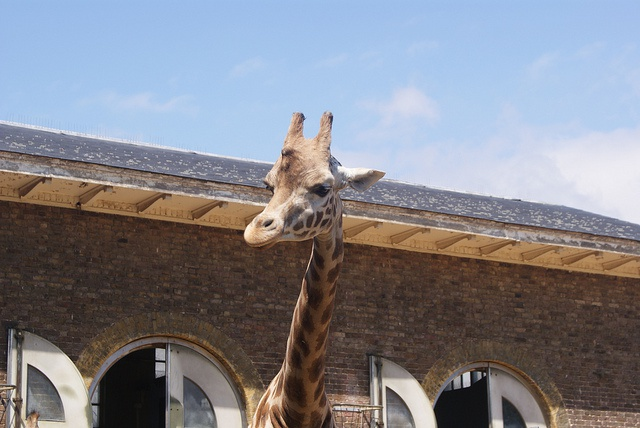Describe the objects in this image and their specific colors. I can see a giraffe in lightblue, black, maroon, and gray tones in this image. 